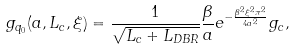<formula> <loc_0><loc_0><loc_500><loc_500>g _ { q _ { 0 } } ( a , L _ { c } , \xi ) = \frac { 1 } { \sqrt { L _ { c } + L _ { D B R } } } \frac { \beta } { a } e ^ { - \frac { \beta ^ { 2 } \xi ^ { 2 } \pi ^ { 2 } } { 4 a ^ { 2 } } } g _ { c } ,</formula> 